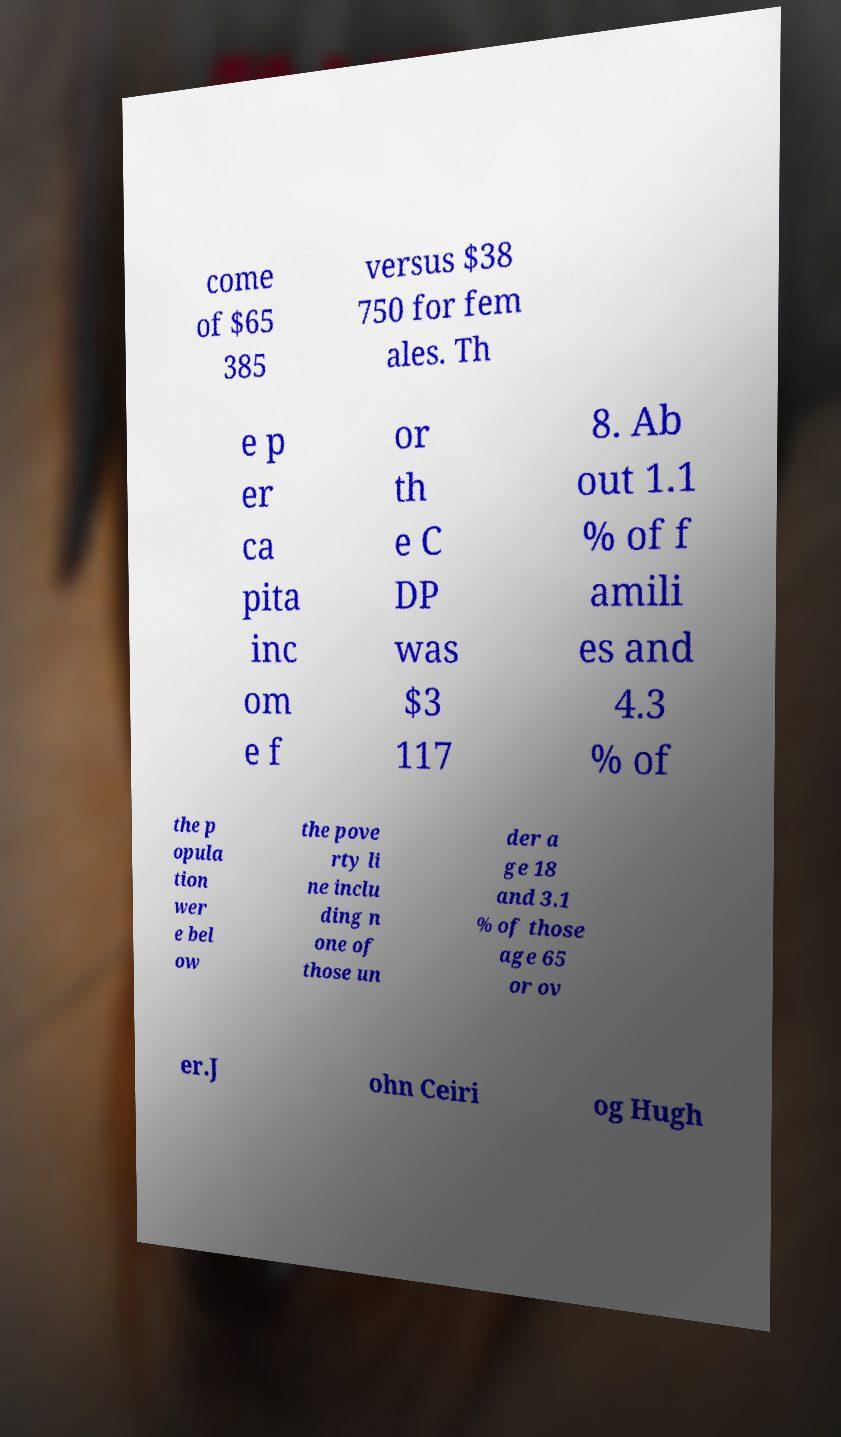Can you read and provide the text displayed in the image?This photo seems to have some interesting text. Can you extract and type it out for me? come of $65 385 versus $38 750 for fem ales. Th e p er ca pita inc om e f or th e C DP was $3 117 8. Ab out 1.1 % of f amili es and 4.3 % of the p opula tion wer e bel ow the pove rty li ne inclu ding n one of those un der a ge 18 and 3.1 % of those age 65 or ov er.J ohn Ceiri og Hugh 